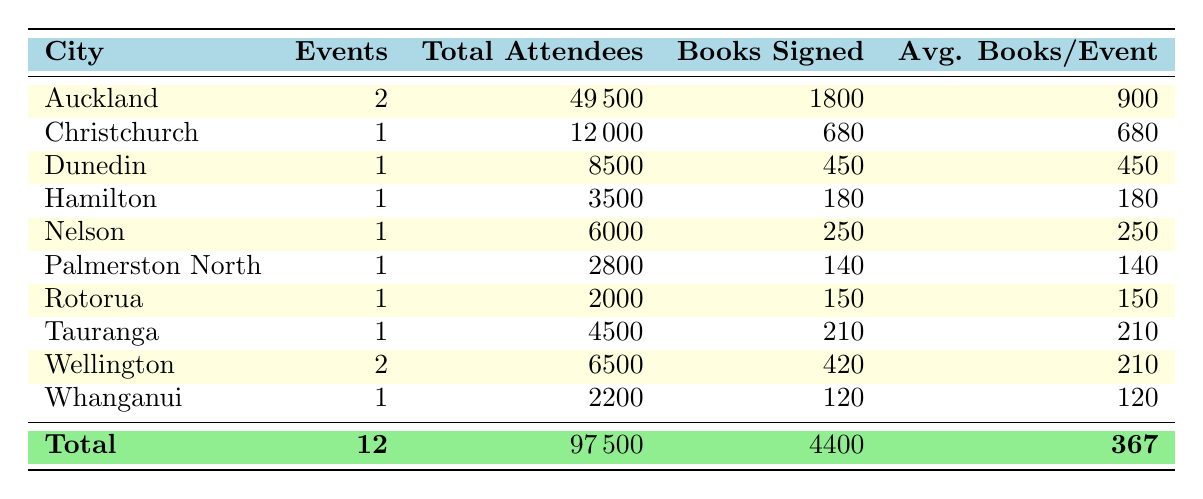What city had the highest total attendance? Auckland had the highest total attendance with 49,500 attendees from its two events combined.
Answer: Auckland How many total books were signed across all events? The total number of books signed across all events is calculated by adding the books signed from each city: 1800 + 680 + 450 + 180 + 250 + 140 + 150 + 210 + 420 + 120 = 4400.
Answer: 4400 Is the average number of books signed per event higher in Auckland than in Wellington? Auckland's average is 900 (1800 books signed/2 events), while Wellington's average is 210 (420 books signed/2 events). Thus, yes, Auckland's average is higher.
Answer: Yes What is the total number of events recorded in the table? The total number of events recorded is simply the count of distinct events listed, which sums to 12.
Answer: 12 Which city had the lowest books signed, and what was that number? Rotorua had the lowest books signed at 150, as the data shows.
Answer: Rotorua, 150 